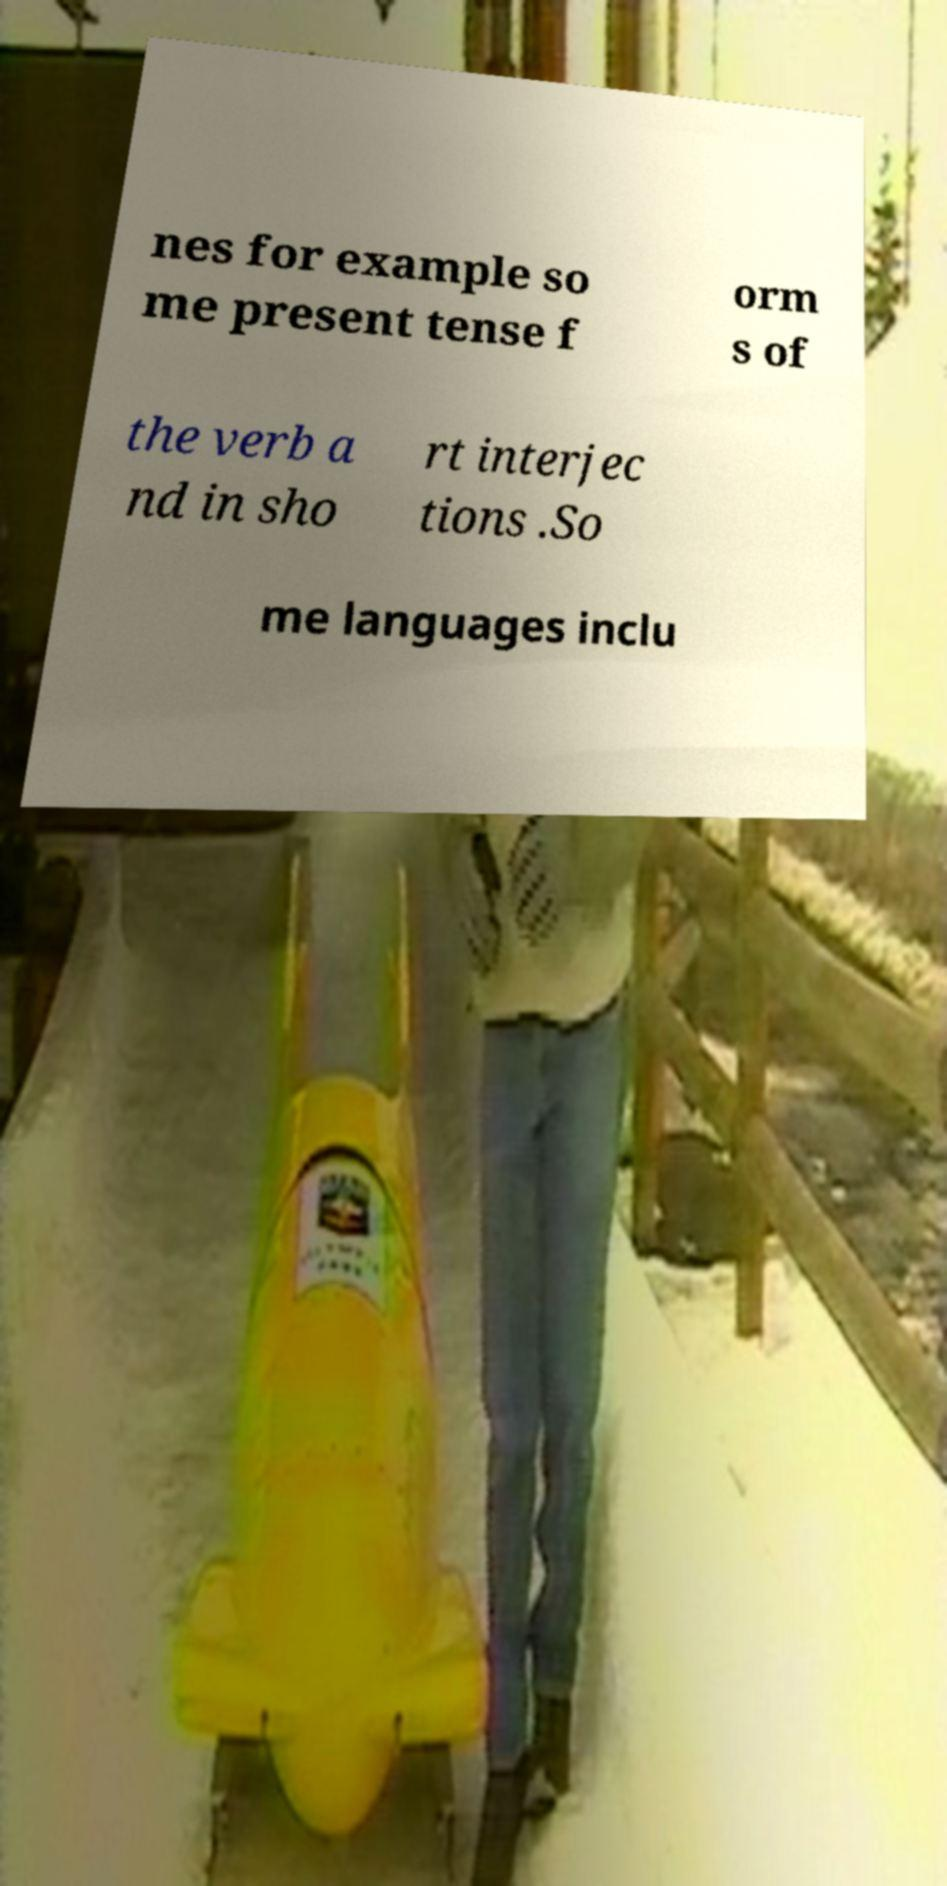Please read and relay the text visible in this image. What does it say? nes for example so me present tense f orm s of the verb a nd in sho rt interjec tions .So me languages inclu 